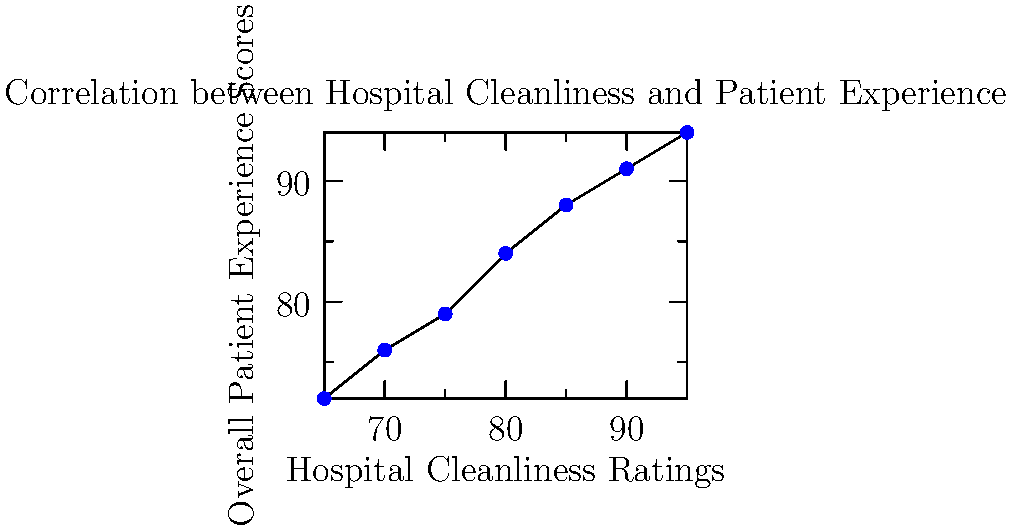Based on the scatter plot comparing hospital cleanliness ratings with overall patient experience scores, what type of correlation is observed between these two variables? To determine the type of correlation between hospital cleanliness ratings and overall patient experience scores, let's analyze the scatter plot step-by-step:

1. Observe the general trend: As we move from left to right (increasing cleanliness ratings), we see that the points tend to move upward (increasing patient experience scores).

2. Direction of the relationship: The upward trend indicates a positive relationship between the two variables.

3. Strength of the relationship: The points form a relatively tight pattern around an imaginary line, suggesting a strong relationship.

4. Linearity: The points appear to follow a roughly straight line pattern, indicating a linear relationship.

5. Consistency: There are no obvious outliers or clusters that deviate significantly from the overall pattern.

Given these observations, we can conclude that the scatter plot shows a strong, positive, linear correlation between hospital cleanliness ratings and overall patient experience scores. This means that as hospital cleanliness ratings increase, overall patient experience scores tend to increase as well, in a consistent and predictable manner.
Answer: Strong positive linear correlation 